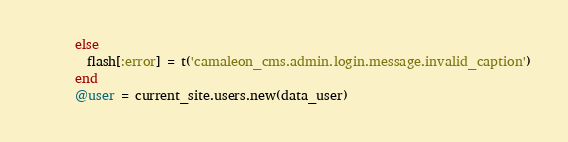Convert code to text. <code><loc_0><loc_0><loc_500><loc_500><_Ruby_>      else
        flash[:error] = t('camaleon_cms.admin.login.message.invalid_caption')
      end
      @user = current_site.users.new(data_user)</code> 